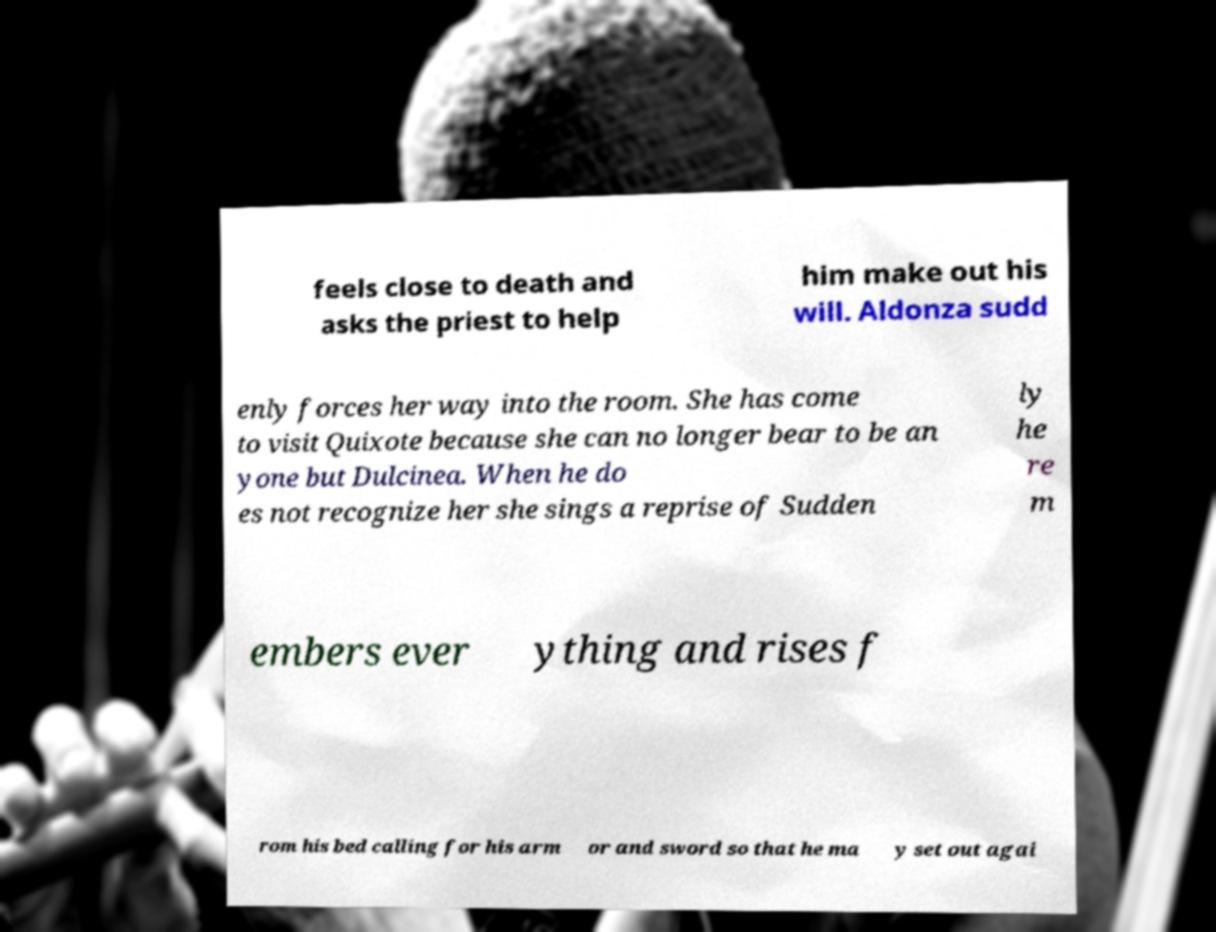Please identify and transcribe the text found in this image. feels close to death and asks the priest to help him make out his will. Aldonza sudd enly forces her way into the room. She has come to visit Quixote because she can no longer bear to be an yone but Dulcinea. When he do es not recognize her she sings a reprise of Sudden ly he re m embers ever ything and rises f rom his bed calling for his arm or and sword so that he ma y set out agai 